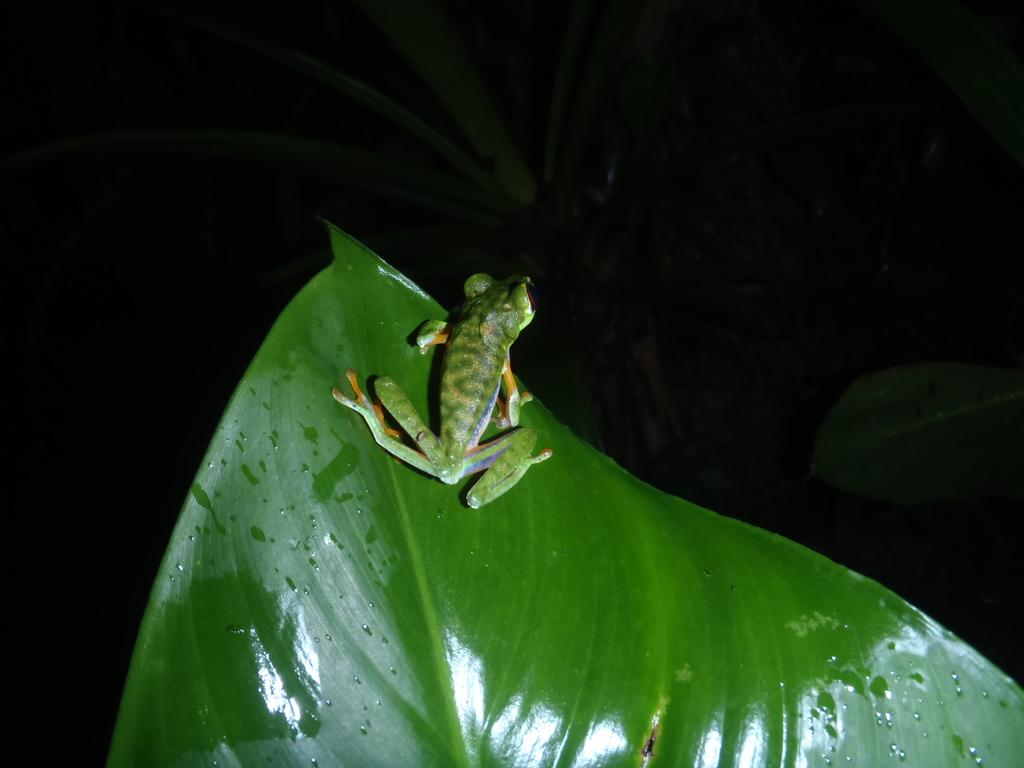What is the main subject of the image? The main subject of the image is a frog. What color is the frog? The frog is green in color. Where is the frog located in the image? The frog is on a leaf. What type of stocking is the frog wearing in the image? There is no stocking present on the frog in the image. What role does the frog play in the society depicted in the image? There is no society depicted in the image, and the frog's role in any society is not mentioned. 